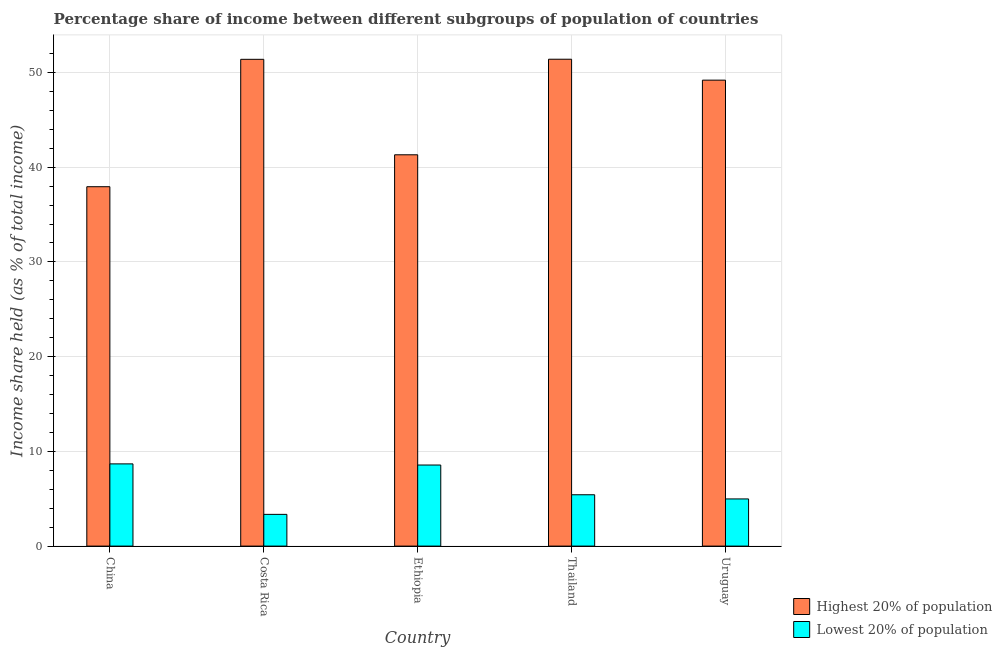How many different coloured bars are there?
Your answer should be very brief. 2. Are the number of bars per tick equal to the number of legend labels?
Give a very brief answer. Yes. Are the number of bars on each tick of the X-axis equal?
Make the answer very short. Yes. What is the label of the 2nd group of bars from the left?
Ensure brevity in your answer.  Costa Rica. What is the income share held by lowest 20% of the population in China?
Keep it short and to the point. 8.68. Across all countries, what is the maximum income share held by highest 20% of the population?
Offer a very short reply. 51.4. Across all countries, what is the minimum income share held by highest 20% of the population?
Your response must be concise. 37.94. In which country was the income share held by highest 20% of the population minimum?
Your response must be concise. China. What is the total income share held by highest 20% of the population in the graph?
Keep it short and to the point. 231.23. What is the difference between the income share held by lowest 20% of the population in China and that in Thailand?
Offer a terse response. 3.26. What is the difference between the income share held by highest 20% of the population in Costa Rica and the income share held by lowest 20% of the population in Ethiopia?
Offer a very short reply. 42.83. What is the average income share held by highest 20% of the population per country?
Your answer should be very brief. 46.25. What is the difference between the income share held by highest 20% of the population and income share held by lowest 20% of the population in Ethiopia?
Your response must be concise. 32.75. What is the ratio of the income share held by lowest 20% of the population in China to that in Thailand?
Offer a terse response. 1.6. Is the income share held by lowest 20% of the population in Costa Rica less than that in Thailand?
Give a very brief answer. Yes. Is the difference between the income share held by highest 20% of the population in China and Thailand greater than the difference between the income share held by lowest 20% of the population in China and Thailand?
Offer a very short reply. No. What is the difference between the highest and the second highest income share held by lowest 20% of the population?
Provide a succinct answer. 0.12. What is the difference between the highest and the lowest income share held by lowest 20% of the population?
Offer a very short reply. 5.33. In how many countries, is the income share held by highest 20% of the population greater than the average income share held by highest 20% of the population taken over all countries?
Keep it short and to the point. 3. What does the 2nd bar from the left in Costa Rica represents?
Your answer should be very brief. Lowest 20% of population. What does the 2nd bar from the right in China represents?
Your response must be concise. Highest 20% of population. What is the difference between two consecutive major ticks on the Y-axis?
Your answer should be compact. 10. Does the graph contain any zero values?
Your response must be concise. No. How many legend labels are there?
Provide a succinct answer. 2. How are the legend labels stacked?
Provide a succinct answer. Vertical. What is the title of the graph?
Provide a short and direct response. Percentage share of income between different subgroups of population of countries. What is the label or title of the X-axis?
Your answer should be compact. Country. What is the label or title of the Y-axis?
Your response must be concise. Income share held (as % of total income). What is the Income share held (as % of total income) of Highest 20% of population in China?
Offer a terse response. 37.94. What is the Income share held (as % of total income) of Lowest 20% of population in China?
Your response must be concise. 8.68. What is the Income share held (as % of total income) of Highest 20% of population in Costa Rica?
Provide a short and direct response. 51.39. What is the Income share held (as % of total income) in Lowest 20% of population in Costa Rica?
Provide a succinct answer. 3.35. What is the Income share held (as % of total income) in Highest 20% of population in Ethiopia?
Offer a terse response. 41.31. What is the Income share held (as % of total income) in Lowest 20% of population in Ethiopia?
Ensure brevity in your answer.  8.56. What is the Income share held (as % of total income) of Highest 20% of population in Thailand?
Offer a terse response. 51.4. What is the Income share held (as % of total income) of Lowest 20% of population in Thailand?
Your answer should be very brief. 5.42. What is the Income share held (as % of total income) in Highest 20% of population in Uruguay?
Your response must be concise. 49.19. What is the Income share held (as % of total income) in Lowest 20% of population in Uruguay?
Offer a very short reply. 4.98. Across all countries, what is the maximum Income share held (as % of total income) of Highest 20% of population?
Your answer should be very brief. 51.4. Across all countries, what is the maximum Income share held (as % of total income) in Lowest 20% of population?
Your response must be concise. 8.68. Across all countries, what is the minimum Income share held (as % of total income) of Highest 20% of population?
Make the answer very short. 37.94. Across all countries, what is the minimum Income share held (as % of total income) of Lowest 20% of population?
Ensure brevity in your answer.  3.35. What is the total Income share held (as % of total income) in Highest 20% of population in the graph?
Your response must be concise. 231.23. What is the total Income share held (as % of total income) of Lowest 20% of population in the graph?
Your answer should be very brief. 30.99. What is the difference between the Income share held (as % of total income) in Highest 20% of population in China and that in Costa Rica?
Give a very brief answer. -13.45. What is the difference between the Income share held (as % of total income) of Lowest 20% of population in China and that in Costa Rica?
Your response must be concise. 5.33. What is the difference between the Income share held (as % of total income) of Highest 20% of population in China and that in Ethiopia?
Provide a short and direct response. -3.37. What is the difference between the Income share held (as % of total income) in Lowest 20% of population in China and that in Ethiopia?
Ensure brevity in your answer.  0.12. What is the difference between the Income share held (as % of total income) in Highest 20% of population in China and that in Thailand?
Give a very brief answer. -13.46. What is the difference between the Income share held (as % of total income) of Lowest 20% of population in China and that in Thailand?
Offer a terse response. 3.26. What is the difference between the Income share held (as % of total income) in Highest 20% of population in China and that in Uruguay?
Your response must be concise. -11.25. What is the difference between the Income share held (as % of total income) of Highest 20% of population in Costa Rica and that in Ethiopia?
Your answer should be very brief. 10.08. What is the difference between the Income share held (as % of total income) in Lowest 20% of population in Costa Rica and that in Ethiopia?
Provide a succinct answer. -5.21. What is the difference between the Income share held (as % of total income) in Highest 20% of population in Costa Rica and that in Thailand?
Provide a short and direct response. -0.01. What is the difference between the Income share held (as % of total income) of Lowest 20% of population in Costa Rica and that in Thailand?
Ensure brevity in your answer.  -2.07. What is the difference between the Income share held (as % of total income) of Highest 20% of population in Costa Rica and that in Uruguay?
Your answer should be very brief. 2.2. What is the difference between the Income share held (as % of total income) in Lowest 20% of population in Costa Rica and that in Uruguay?
Your answer should be very brief. -1.63. What is the difference between the Income share held (as % of total income) of Highest 20% of population in Ethiopia and that in Thailand?
Provide a succinct answer. -10.09. What is the difference between the Income share held (as % of total income) in Lowest 20% of population in Ethiopia and that in Thailand?
Provide a short and direct response. 3.14. What is the difference between the Income share held (as % of total income) of Highest 20% of population in Ethiopia and that in Uruguay?
Offer a terse response. -7.88. What is the difference between the Income share held (as % of total income) in Lowest 20% of population in Ethiopia and that in Uruguay?
Offer a terse response. 3.58. What is the difference between the Income share held (as % of total income) of Highest 20% of population in Thailand and that in Uruguay?
Your response must be concise. 2.21. What is the difference between the Income share held (as % of total income) of Lowest 20% of population in Thailand and that in Uruguay?
Your answer should be very brief. 0.44. What is the difference between the Income share held (as % of total income) in Highest 20% of population in China and the Income share held (as % of total income) in Lowest 20% of population in Costa Rica?
Ensure brevity in your answer.  34.59. What is the difference between the Income share held (as % of total income) in Highest 20% of population in China and the Income share held (as % of total income) in Lowest 20% of population in Ethiopia?
Keep it short and to the point. 29.38. What is the difference between the Income share held (as % of total income) of Highest 20% of population in China and the Income share held (as % of total income) of Lowest 20% of population in Thailand?
Offer a terse response. 32.52. What is the difference between the Income share held (as % of total income) in Highest 20% of population in China and the Income share held (as % of total income) in Lowest 20% of population in Uruguay?
Your answer should be very brief. 32.96. What is the difference between the Income share held (as % of total income) in Highest 20% of population in Costa Rica and the Income share held (as % of total income) in Lowest 20% of population in Ethiopia?
Offer a very short reply. 42.83. What is the difference between the Income share held (as % of total income) in Highest 20% of population in Costa Rica and the Income share held (as % of total income) in Lowest 20% of population in Thailand?
Keep it short and to the point. 45.97. What is the difference between the Income share held (as % of total income) of Highest 20% of population in Costa Rica and the Income share held (as % of total income) of Lowest 20% of population in Uruguay?
Keep it short and to the point. 46.41. What is the difference between the Income share held (as % of total income) of Highest 20% of population in Ethiopia and the Income share held (as % of total income) of Lowest 20% of population in Thailand?
Keep it short and to the point. 35.89. What is the difference between the Income share held (as % of total income) of Highest 20% of population in Ethiopia and the Income share held (as % of total income) of Lowest 20% of population in Uruguay?
Your answer should be compact. 36.33. What is the difference between the Income share held (as % of total income) of Highest 20% of population in Thailand and the Income share held (as % of total income) of Lowest 20% of population in Uruguay?
Provide a short and direct response. 46.42. What is the average Income share held (as % of total income) of Highest 20% of population per country?
Keep it short and to the point. 46.25. What is the average Income share held (as % of total income) in Lowest 20% of population per country?
Your response must be concise. 6.2. What is the difference between the Income share held (as % of total income) of Highest 20% of population and Income share held (as % of total income) of Lowest 20% of population in China?
Offer a terse response. 29.26. What is the difference between the Income share held (as % of total income) in Highest 20% of population and Income share held (as % of total income) in Lowest 20% of population in Costa Rica?
Offer a terse response. 48.04. What is the difference between the Income share held (as % of total income) of Highest 20% of population and Income share held (as % of total income) of Lowest 20% of population in Ethiopia?
Your answer should be very brief. 32.75. What is the difference between the Income share held (as % of total income) in Highest 20% of population and Income share held (as % of total income) in Lowest 20% of population in Thailand?
Give a very brief answer. 45.98. What is the difference between the Income share held (as % of total income) in Highest 20% of population and Income share held (as % of total income) in Lowest 20% of population in Uruguay?
Provide a short and direct response. 44.21. What is the ratio of the Income share held (as % of total income) of Highest 20% of population in China to that in Costa Rica?
Make the answer very short. 0.74. What is the ratio of the Income share held (as % of total income) of Lowest 20% of population in China to that in Costa Rica?
Provide a short and direct response. 2.59. What is the ratio of the Income share held (as % of total income) of Highest 20% of population in China to that in Ethiopia?
Make the answer very short. 0.92. What is the ratio of the Income share held (as % of total income) in Lowest 20% of population in China to that in Ethiopia?
Make the answer very short. 1.01. What is the ratio of the Income share held (as % of total income) of Highest 20% of population in China to that in Thailand?
Keep it short and to the point. 0.74. What is the ratio of the Income share held (as % of total income) of Lowest 20% of population in China to that in Thailand?
Ensure brevity in your answer.  1.6. What is the ratio of the Income share held (as % of total income) of Highest 20% of population in China to that in Uruguay?
Offer a very short reply. 0.77. What is the ratio of the Income share held (as % of total income) in Lowest 20% of population in China to that in Uruguay?
Give a very brief answer. 1.74. What is the ratio of the Income share held (as % of total income) in Highest 20% of population in Costa Rica to that in Ethiopia?
Provide a succinct answer. 1.24. What is the ratio of the Income share held (as % of total income) of Lowest 20% of population in Costa Rica to that in Ethiopia?
Offer a very short reply. 0.39. What is the ratio of the Income share held (as % of total income) in Lowest 20% of population in Costa Rica to that in Thailand?
Your answer should be very brief. 0.62. What is the ratio of the Income share held (as % of total income) of Highest 20% of population in Costa Rica to that in Uruguay?
Provide a short and direct response. 1.04. What is the ratio of the Income share held (as % of total income) of Lowest 20% of population in Costa Rica to that in Uruguay?
Your answer should be very brief. 0.67. What is the ratio of the Income share held (as % of total income) of Highest 20% of population in Ethiopia to that in Thailand?
Provide a short and direct response. 0.8. What is the ratio of the Income share held (as % of total income) of Lowest 20% of population in Ethiopia to that in Thailand?
Offer a terse response. 1.58. What is the ratio of the Income share held (as % of total income) of Highest 20% of population in Ethiopia to that in Uruguay?
Ensure brevity in your answer.  0.84. What is the ratio of the Income share held (as % of total income) of Lowest 20% of population in Ethiopia to that in Uruguay?
Provide a succinct answer. 1.72. What is the ratio of the Income share held (as % of total income) of Highest 20% of population in Thailand to that in Uruguay?
Your answer should be compact. 1.04. What is the ratio of the Income share held (as % of total income) in Lowest 20% of population in Thailand to that in Uruguay?
Your response must be concise. 1.09. What is the difference between the highest and the second highest Income share held (as % of total income) of Highest 20% of population?
Give a very brief answer. 0.01. What is the difference between the highest and the second highest Income share held (as % of total income) in Lowest 20% of population?
Give a very brief answer. 0.12. What is the difference between the highest and the lowest Income share held (as % of total income) of Highest 20% of population?
Ensure brevity in your answer.  13.46. What is the difference between the highest and the lowest Income share held (as % of total income) in Lowest 20% of population?
Offer a very short reply. 5.33. 